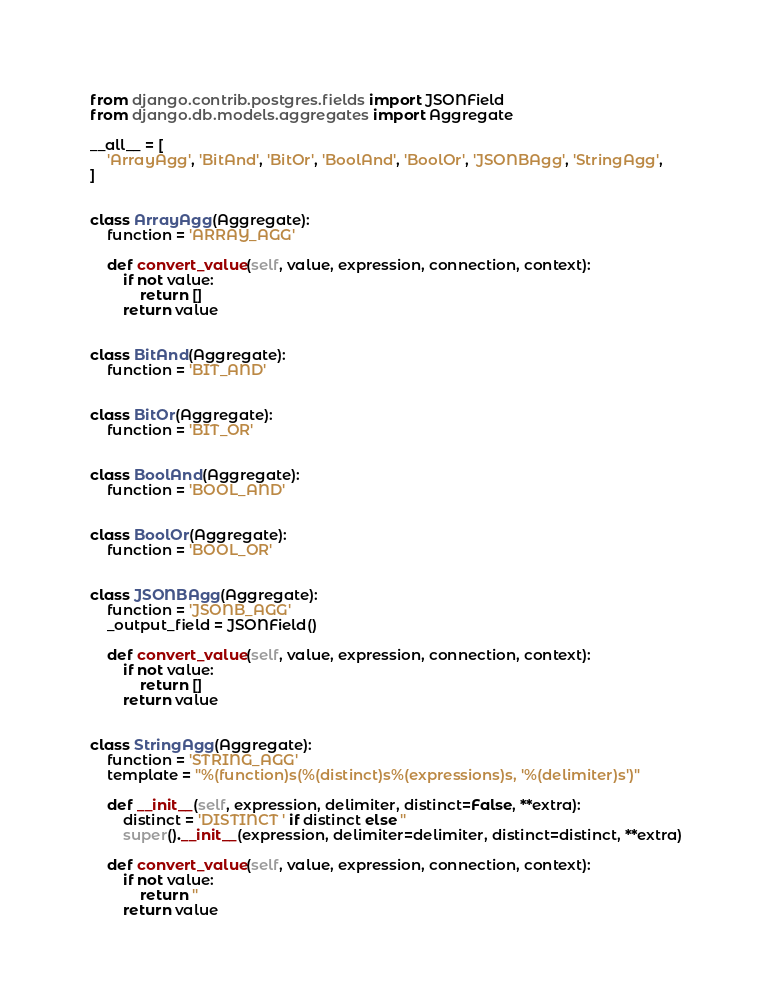<code> <loc_0><loc_0><loc_500><loc_500><_Python_>from django.contrib.postgres.fields import JSONField
from django.db.models.aggregates import Aggregate

__all__ = [
    'ArrayAgg', 'BitAnd', 'BitOr', 'BoolAnd', 'BoolOr', 'JSONBAgg', 'StringAgg',
]


class ArrayAgg(Aggregate):
    function = 'ARRAY_AGG'

    def convert_value(self, value, expression, connection, context):
        if not value:
            return []
        return value


class BitAnd(Aggregate):
    function = 'BIT_AND'


class BitOr(Aggregate):
    function = 'BIT_OR'


class BoolAnd(Aggregate):
    function = 'BOOL_AND'


class BoolOr(Aggregate):
    function = 'BOOL_OR'


class JSONBAgg(Aggregate):
    function = 'JSONB_AGG'
    _output_field = JSONField()

    def convert_value(self, value, expression, connection, context):
        if not value:
            return []
        return value


class StringAgg(Aggregate):
    function = 'STRING_AGG'
    template = "%(function)s(%(distinct)s%(expressions)s, '%(delimiter)s')"

    def __init__(self, expression, delimiter, distinct=False, **extra):
        distinct = 'DISTINCT ' if distinct else ''
        super().__init__(expression, delimiter=delimiter, distinct=distinct, **extra)

    def convert_value(self, value, expression, connection, context):
        if not value:
            return ''
        return value
</code> 